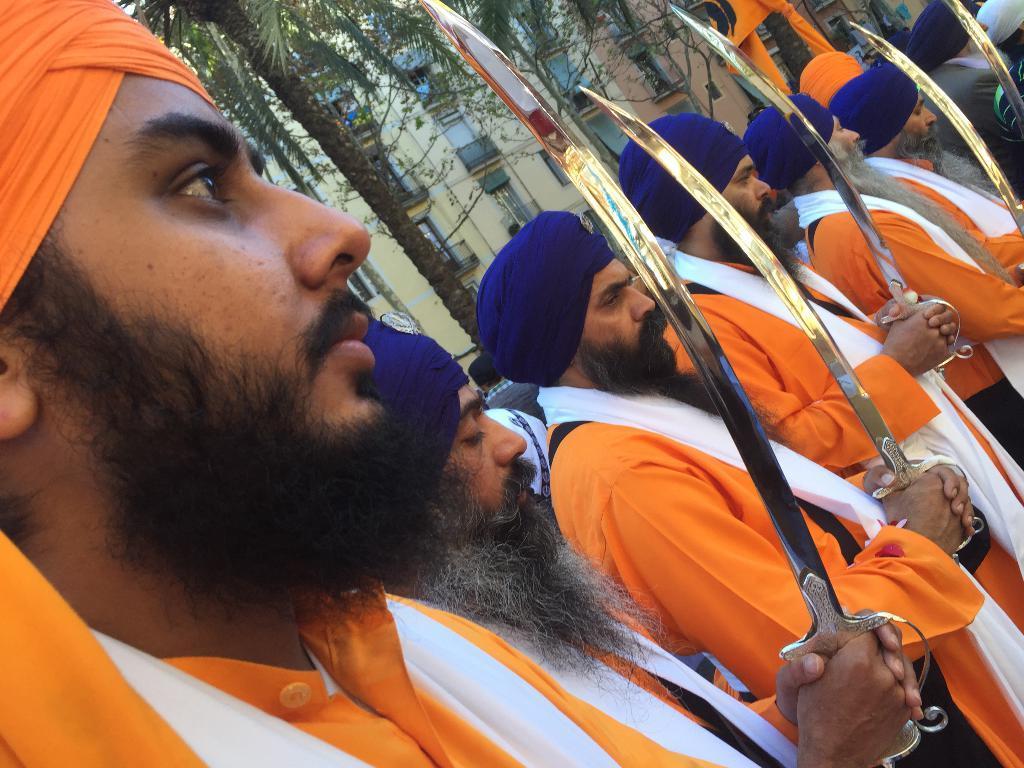Describe this image in one or two sentences. There are some persons standing and holding a sword as we can see at the bottom of this image. There are some trees and building in the background. 